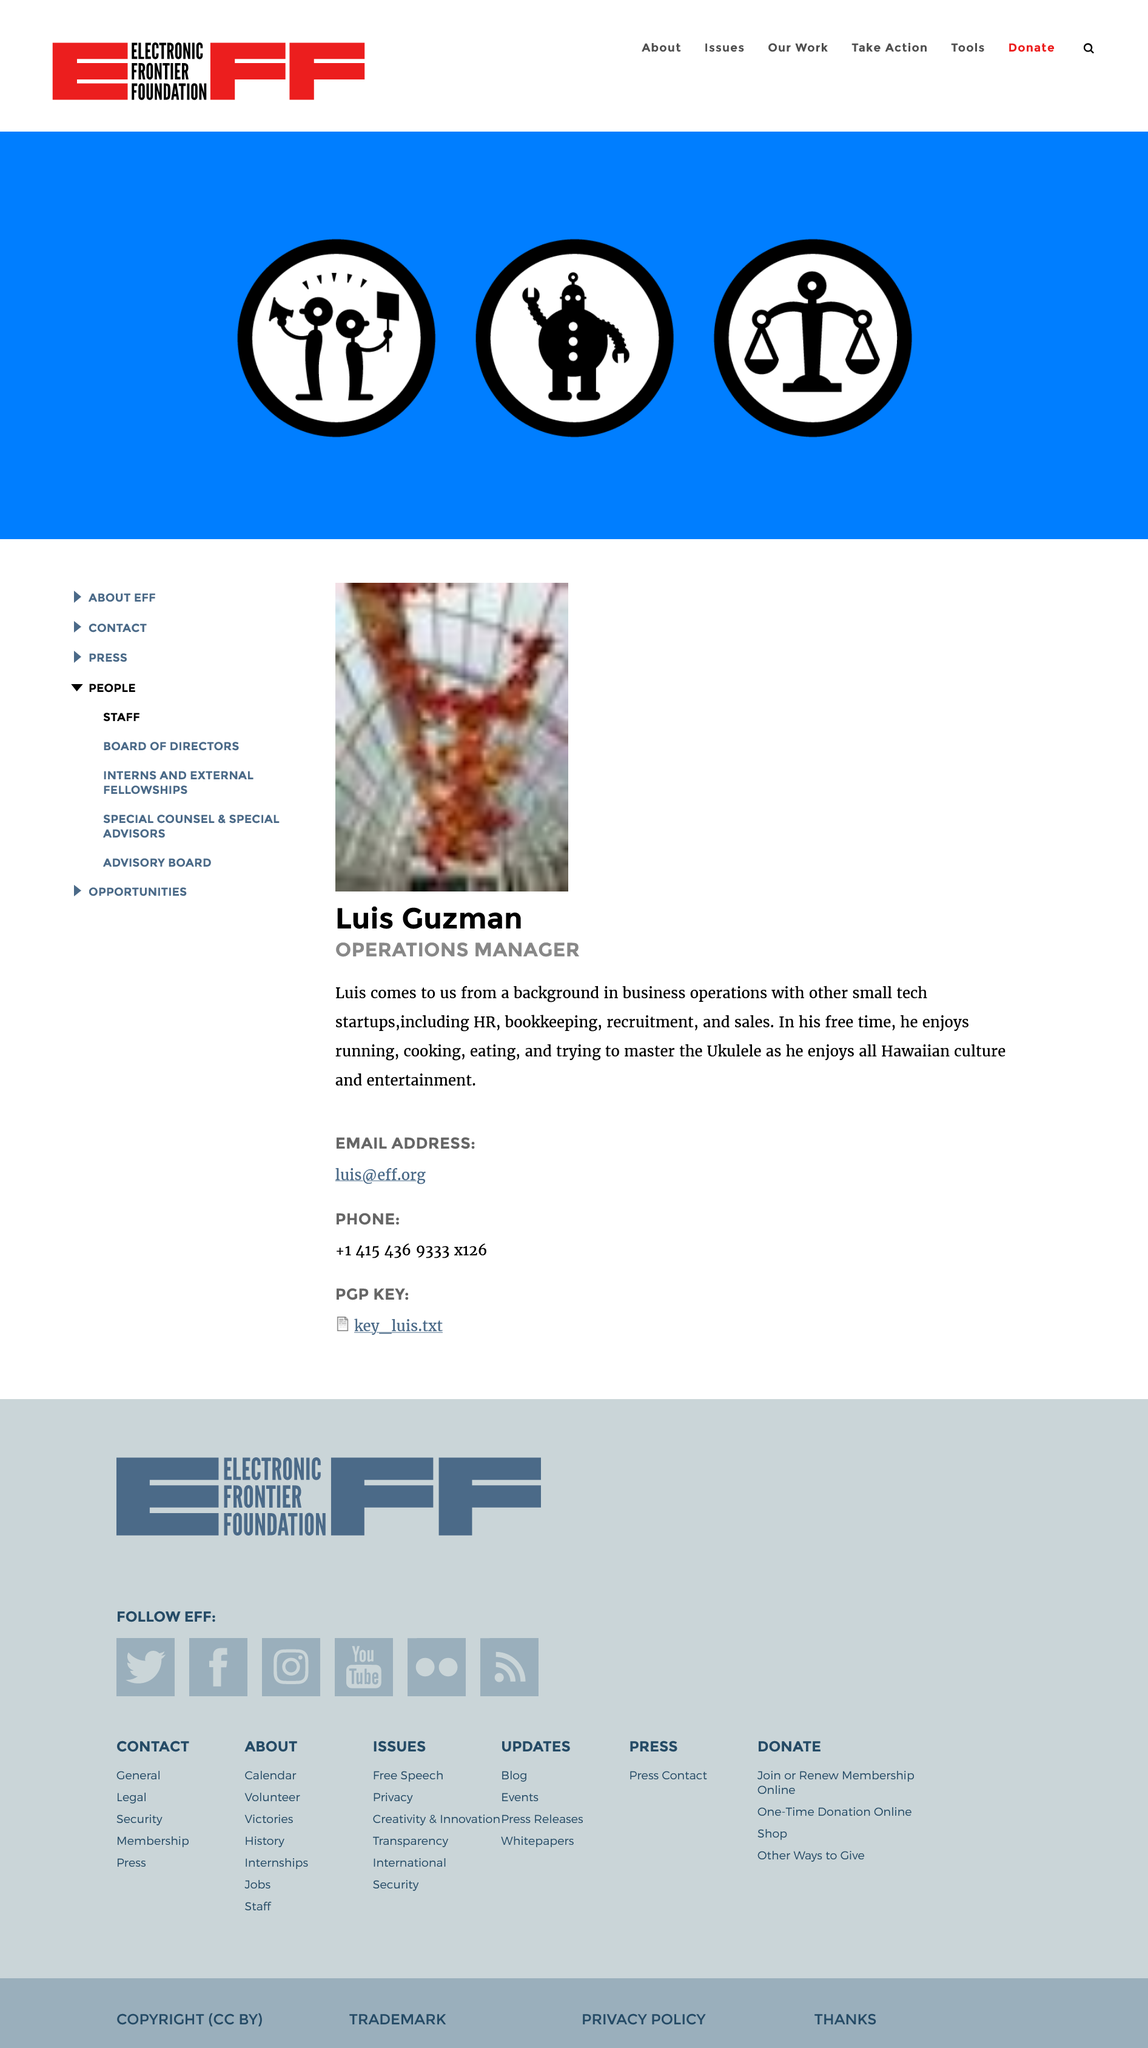Give some essential details in this illustration. The Operations manager is Luis Guzman. Luis Guzman's email address is [luis@eff.org](mailto:luis@eff.org). Luis Guzman is determined to become proficient in playing the ukulele. 